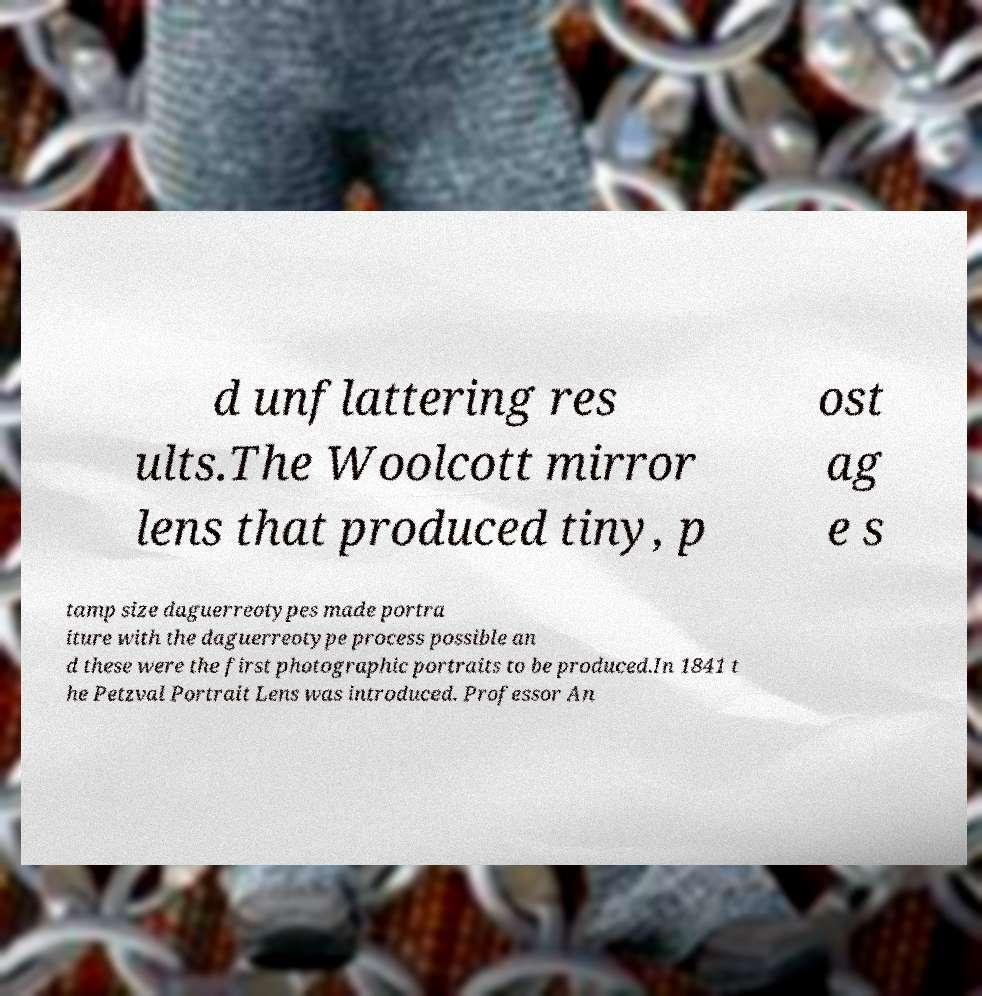Please read and relay the text visible in this image. What does it say? d unflattering res ults.The Woolcott mirror lens that produced tiny, p ost ag e s tamp size daguerreotypes made portra iture with the daguerreotype process possible an d these were the first photographic portraits to be produced.In 1841 t he Petzval Portrait Lens was introduced. Professor An 